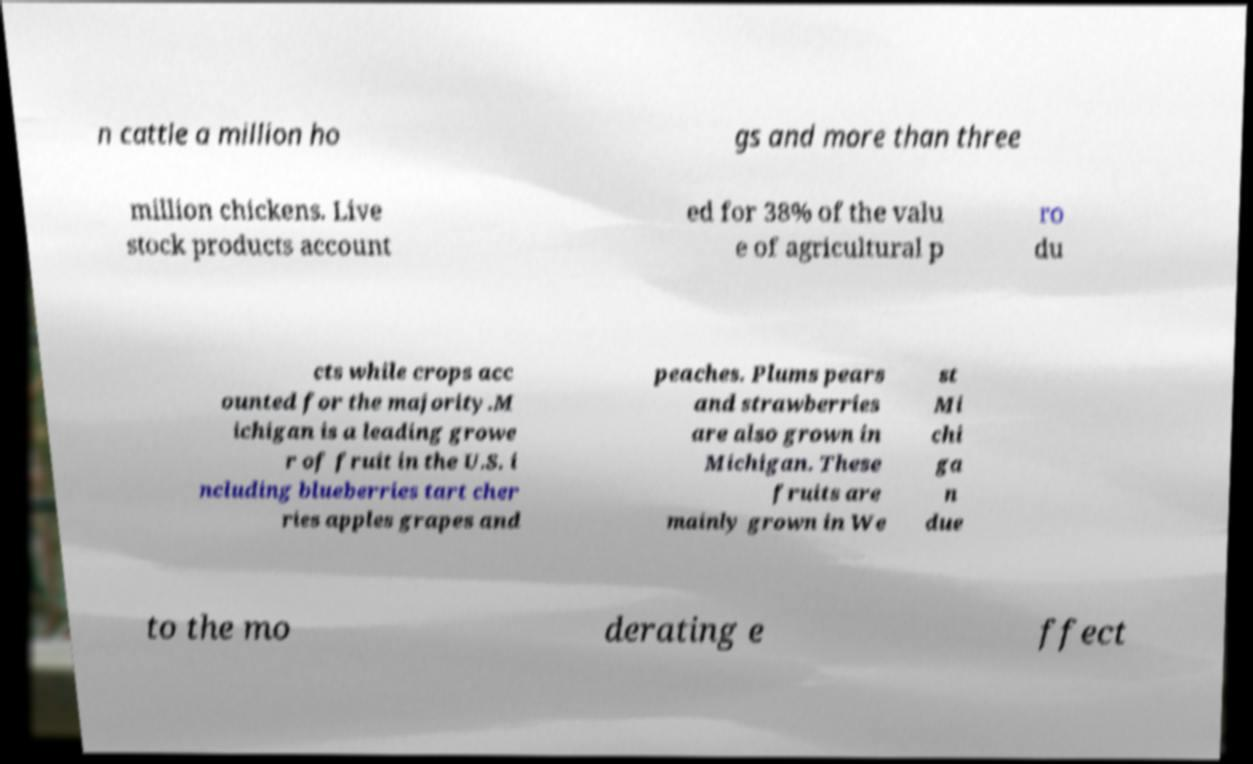Please identify and transcribe the text found in this image. n cattle a million ho gs and more than three million chickens. Live stock products account ed for 38% of the valu e of agricultural p ro du cts while crops acc ounted for the majority.M ichigan is a leading growe r of fruit in the U.S. i ncluding blueberries tart cher ries apples grapes and peaches. Plums pears and strawberries are also grown in Michigan. These fruits are mainly grown in We st Mi chi ga n due to the mo derating e ffect 